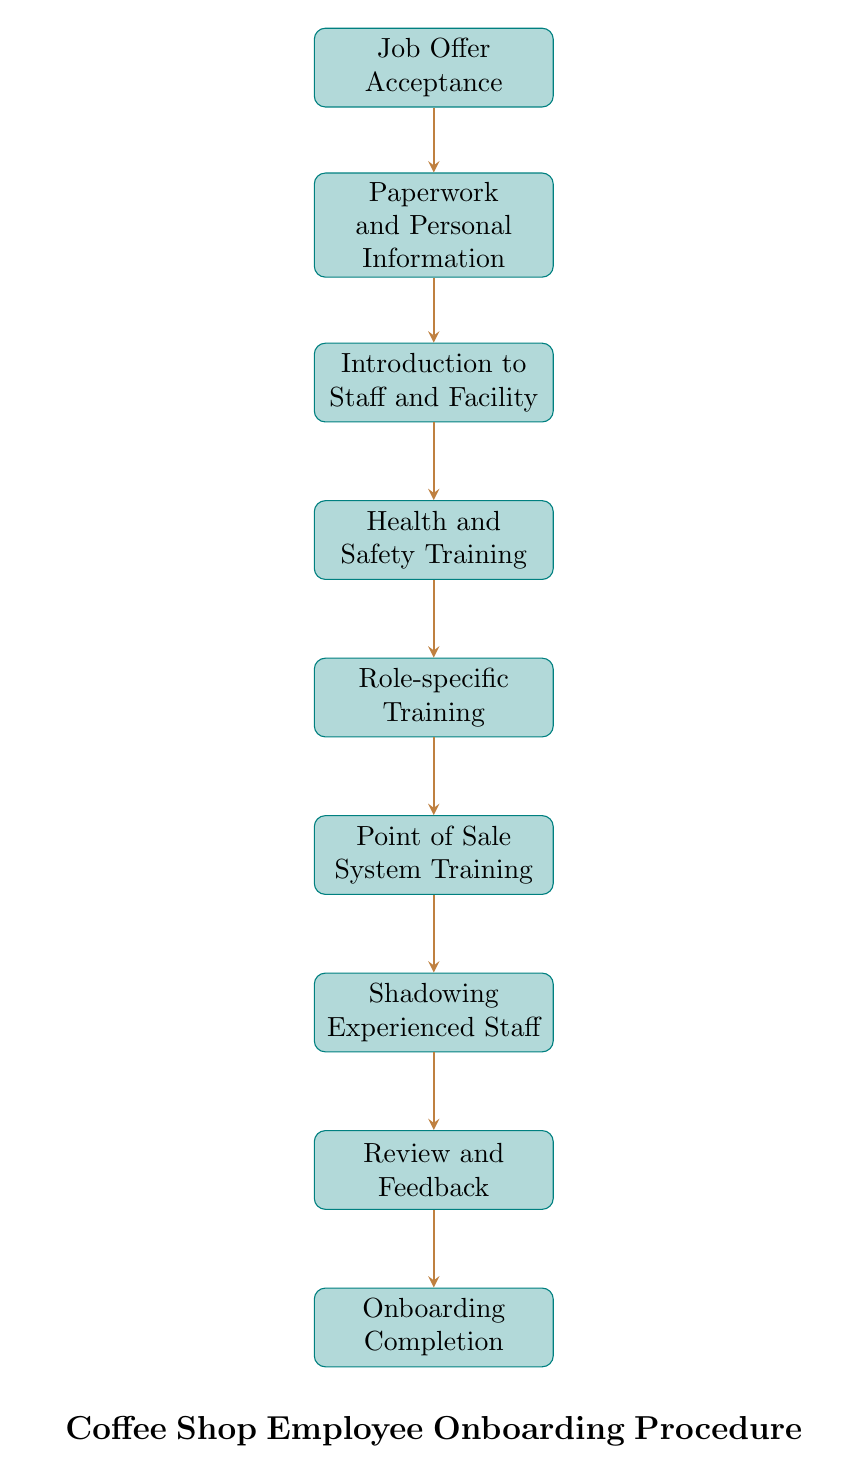What is the starting point of the onboarding procedure? The diagram starts with the "Job Offer Acceptance" node, which is the first step in the onboarding process.
Answer: Job Offer Acceptance How many steps are in the onboarding process? Counting all the nodes in the diagram, there are a total of nine steps from the beginning to the end of the onboarding procedure.
Answer: Nine What comes immediately after "Health and Safety Training"? Following the "Health and Safety Training" node, the next step is "Role-specific Training" as indicated by the flow of arrows connecting the nodes.
Answer: Role-specific Training What is the final step in the onboarding process? The last node in the flow chart is "Onboarding Completion," which signifies the end of the onboarding procedure.
Answer: Onboarding Completion Which step involves training on the Point of Sale system? The node labeled "Point of Sale System Training" is specifically dedicated to this training as depicted in the sequence of the diagram.
Answer: Point of Sale System Training What is the relationship between "Shadowing Experienced Staff" and "Review and Feedback"? "Shadowing Experienced Staff" leads directly to "Review and Feedback," indicating that after shadowing, feedback is provided.
Answer: Shadowing Experienced Staff leads to Review and Feedback What is required before "Role-specific Training"? According to the diagram, "Health and Safety Training" must be completed before proceeding to "Role-specific Training," as shown by the connecting arrow.
Answer: Health and Safety Training What is the purpose of the "Introduction to Staff and Facility" step? This step is aimed at familiarizing the new employee with both their colleagues and the physical work environment, which is an important part of their onboarding.
Answer: Familiarization What precedes the "Paperwork and Personal Information" step? "Job Offer Acceptance" comes directly before the "Paperwork and Personal Information," which is where the new hire provides necessary personal details.
Answer: Job Offer Acceptance 